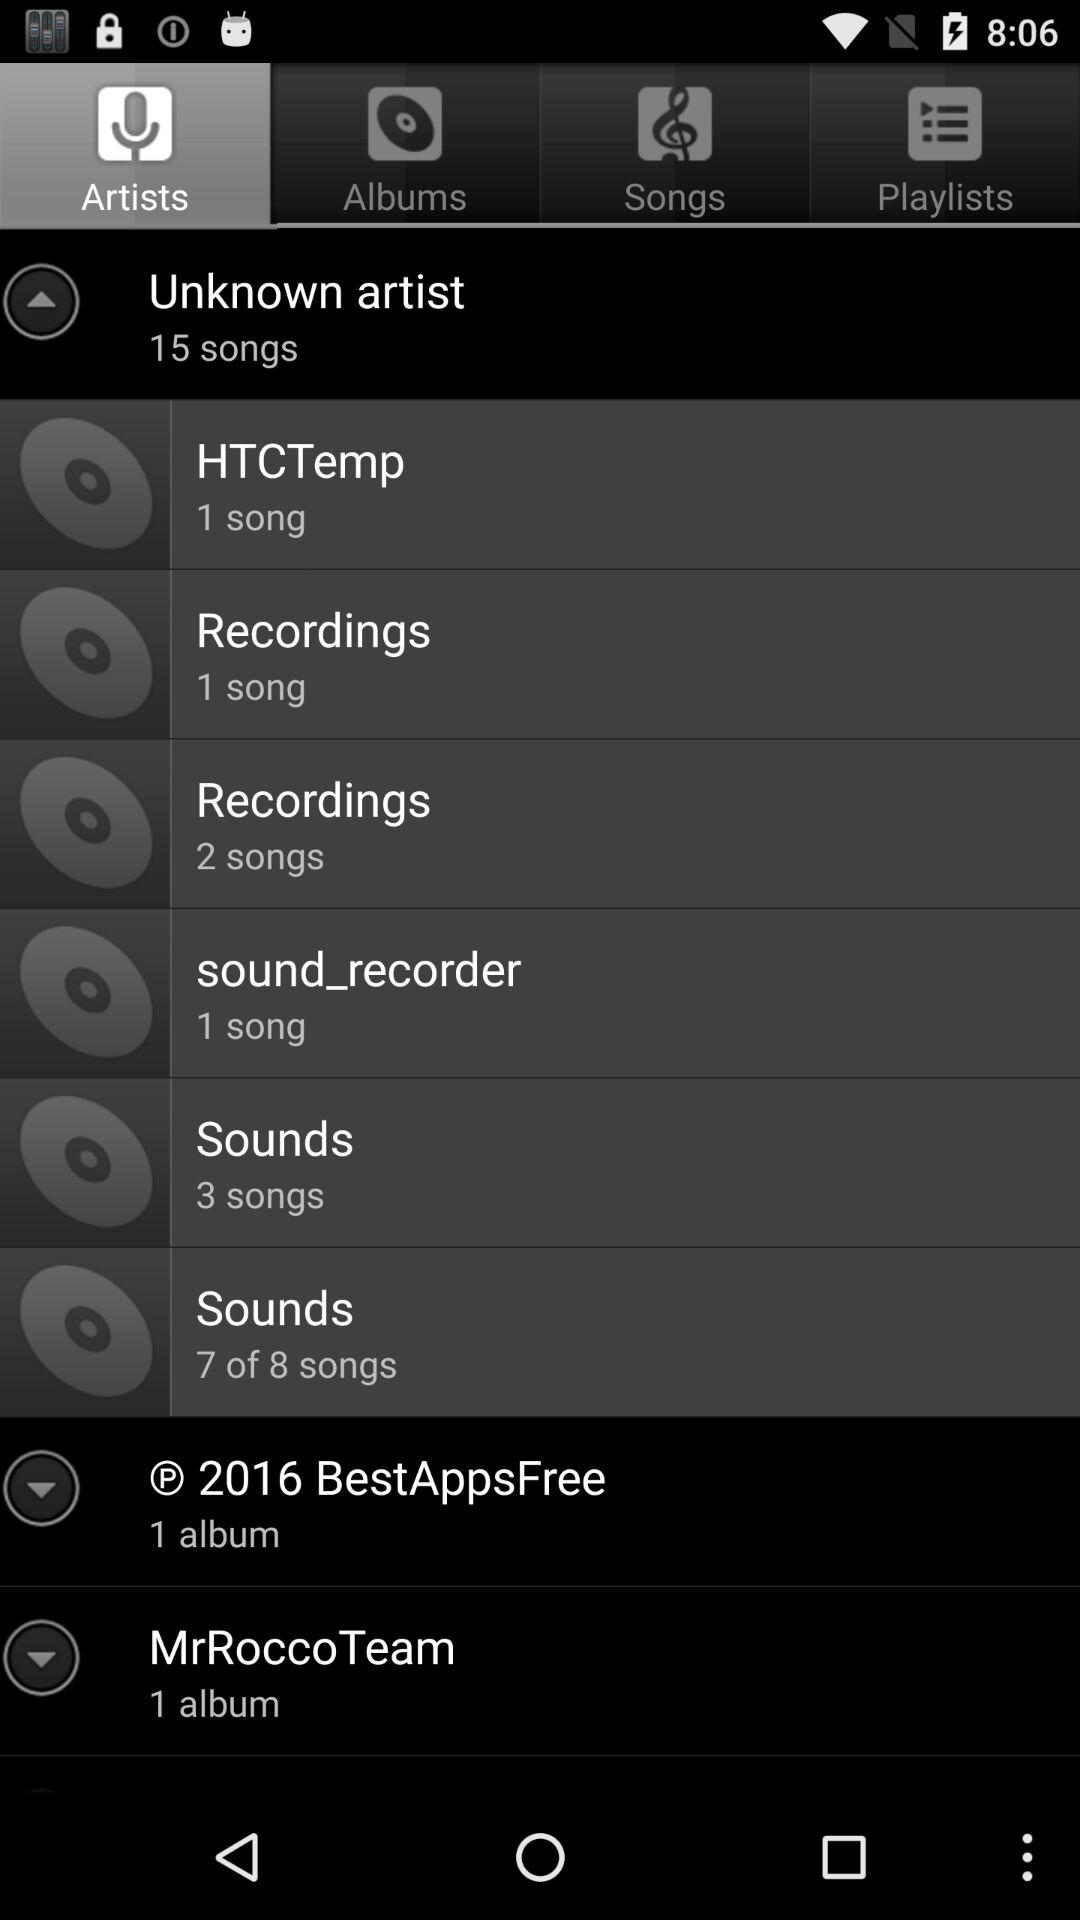How many albums are in "MrRoccoTeam"? There is 1 album in "MrRoccoTeam". 